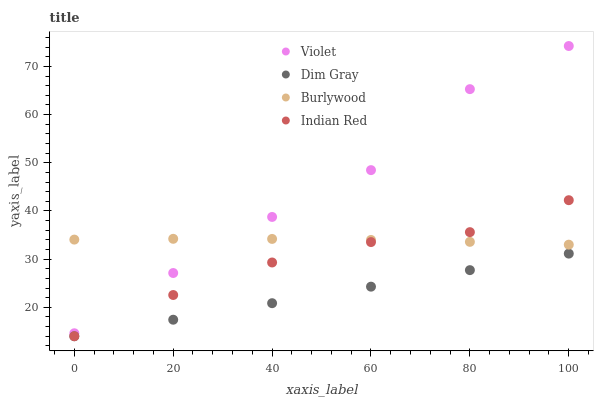Does Dim Gray have the minimum area under the curve?
Answer yes or no. Yes. Does Violet have the maximum area under the curve?
Answer yes or no. Yes. Does Indian Red have the minimum area under the curve?
Answer yes or no. No. Does Indian Red have the maximum area under the curve?
Answer yes or no. No. Is Dim Gray the smoothest?
Answer yes or no. Yes. Is Violet the roughest?
Answer yes or no. Yes. Is Indian Red the smoothest?
Answer yes or no. No. Is Indian Red the roughest?
Answer yes or no. No. Does Dim Gray have the lowest value?
Answer yes or no. Yes. Does Violet have the lowest value?
Answer yes or no. No. Does Violet have the highest value?
Answer yes or no. Yes. Does Indian Red have the highest value?
Answer yes or no. No. Is Dim Gray less than Burlywood?
Answer yes or no. Yes. Is Burlywood greater than Dim Gray?
Answer yes or no. Yes. Does Indian Red intersect Burlywood?
Answer yes or no. Yes. Is Indian Red less than Burlywood?
Answer yes or no. No. Is Indian Red greater than Burlywood?
Answer yes or no. No. Does Dim Gray intersect Burlywood?
Answer yes or no. No. 